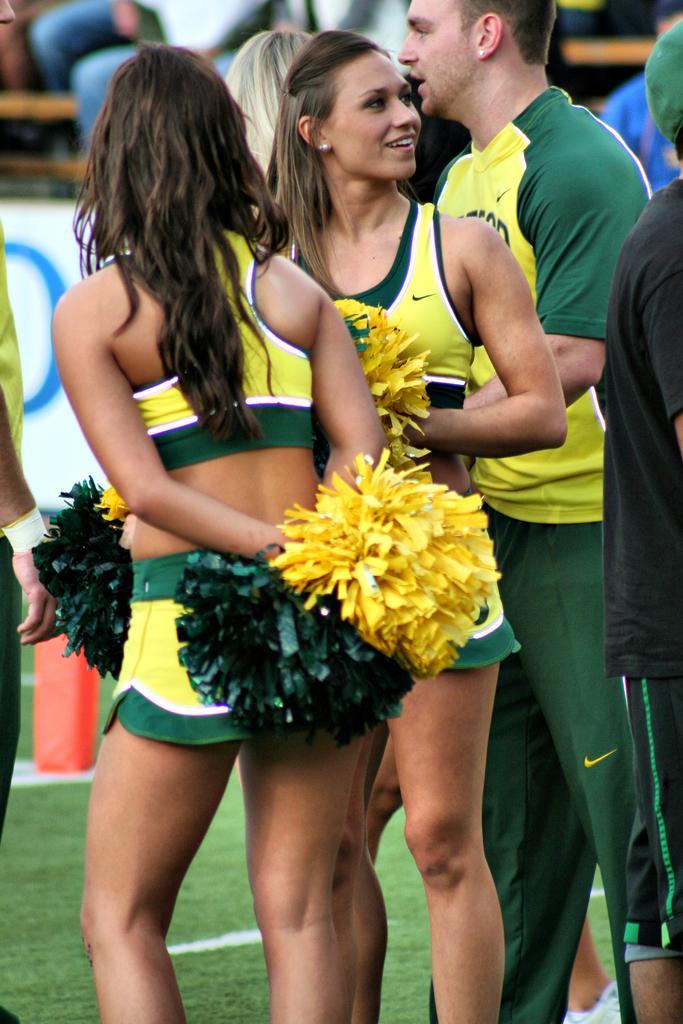How would you summarize this image in a sentence or two? In this picture I can see few people standing on the ground and I can see couple of women holding color papers in their hands. 